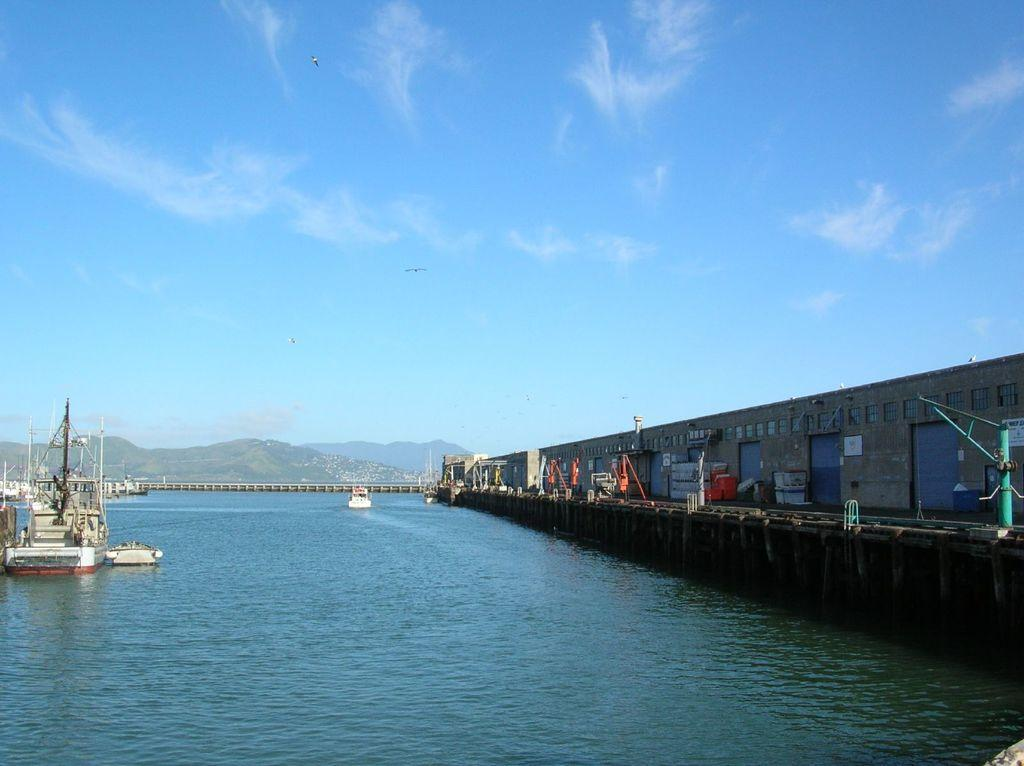What is the main feature of the water surface in the image? There is a ship floating on the water surface in the image. What structure is located near the water surface? There is a bridge beside the water surface in the image. What can be seen in the background of the image? There are mountains visible in the background of the image. How many legs can be seen on the ship in the image? Ships do not have legs; they have hulls and decks. What type of yard is visible in the image? There is no yard present in the image; it features a water surface, a bridge, a ship, and mountains in the background. 